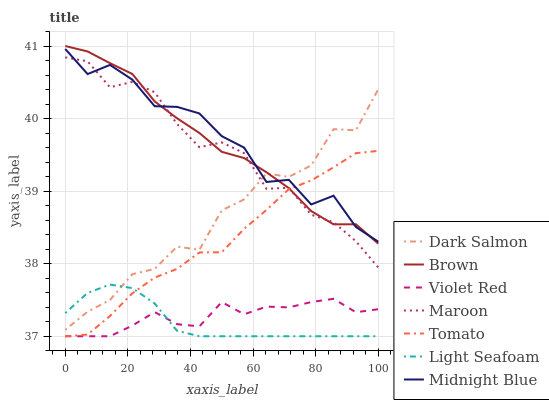Does Brown have the minimum area under the curve?
Answer yes or no. No. Does Brown have the maximum area under the curve?
Answer yes or no. No. Is Brown the smoothest?
Answer yes or no. No. Is Brown the roughest?
Answer yes or no. No. Does Brown have the lowest value?
Answer yes or no. No. Does Violet Red have the highest value?
Answer yes or no. No. Is Violet Red less than Dark Salmon?
Answer yes or no. Yes. Is Dark Salmon greater than Violet Red?
Answer yes or no. Yes. Does Violet Red intersect Dark Salmon?
Answer yes or no. No. 